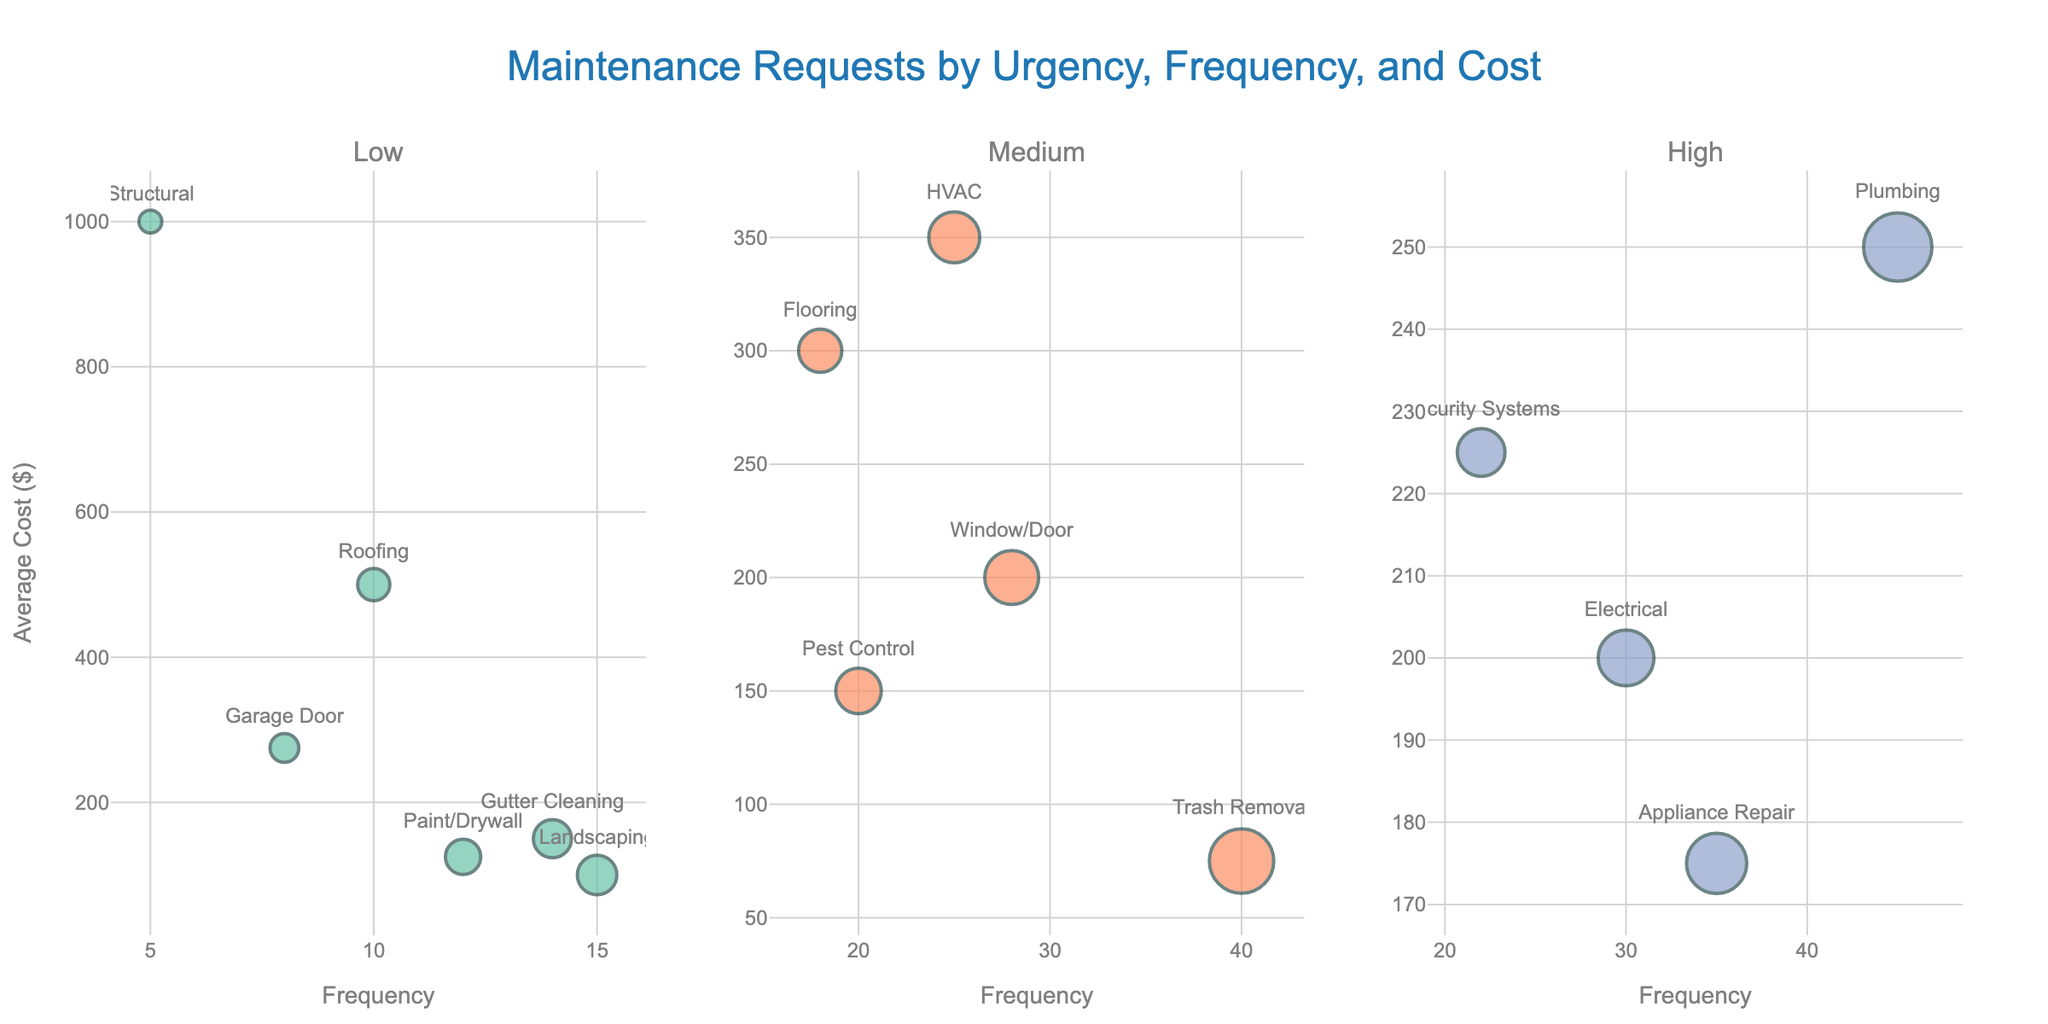Which city had the highest tourism revenue in 2019? Looking at the subplots for each city, identify the data point for the year 2019 and compare them. Bangkok has the highest revenue in 2019.
Answer: Bangkok How did tourism revenue in Paris change from 2020 to 2021? Check the subplot for Paris, observe the data points for 2020 and 2021: it increased from 5.8 billion USD to 8.2 billion USD.
Answer: Increased What is the revenue difference between Tokyo and Rome in 2023? Look at the subplots for Tokyo and Rome, find the 2023 data points: 11.8 billion USD for Tokyo and 9.9 billion USD for Rome. Subtract Rome's value from Tokyo's.
Answer: 1.9 billion USD Among the five cities shown, which experienced the largest drop in tourism revenue from 2019 to 2020? Compare the 2019 and 2020 values for Paris, New York City, Tokyo, Rome, and Bangkok. Calculate the drop for each city. Paris dropped from 19.1 billion USD to 5.8 billion USD (13.3 billion USD drop).
Answer: Paris What were the tourism revenues for New York City in 2018 and 2023? Look at the New York City subplot and read the data points for the years 2018 and 2023: 16.4 billion USD in 2018 and 15.9 billion USD in 2023.
Answer: 16.4 billion USD and 15.9 billion USD Did any city recover to its 2019 revenue level by 2023? Compare each city's 2019 revenue with its 2023 revenue. None of the cities reached or surpassed their 2019 revenue levels by 2023.
Answer: No Which city showed the most consistent recovery from 2020 to 2023? Observe the trends from 2020 to 2023 in all subplots: compare for Paris, New York City, Tokyo, Rome, and Bangkok. Bangkok shows the most consistent upward trend over these years.
Answer: Bangkok What is the total combined revenue for all five cities in 2023? Add the 2023 revenues for Paris, New York City, Tokyo, Rome, and Bangkok: 16.7 + 15.9 + 11.8 + 9.9 + 18.7. The total is 73 billion USD.
Answer: 73 billion USD When did tourism revenue start to recover after the pandemic for Tokyo? Look at Tokyo's subplot, examine the data points after the significant drop in 2020: revenue started to increase in 2021.
Answer: 2021 